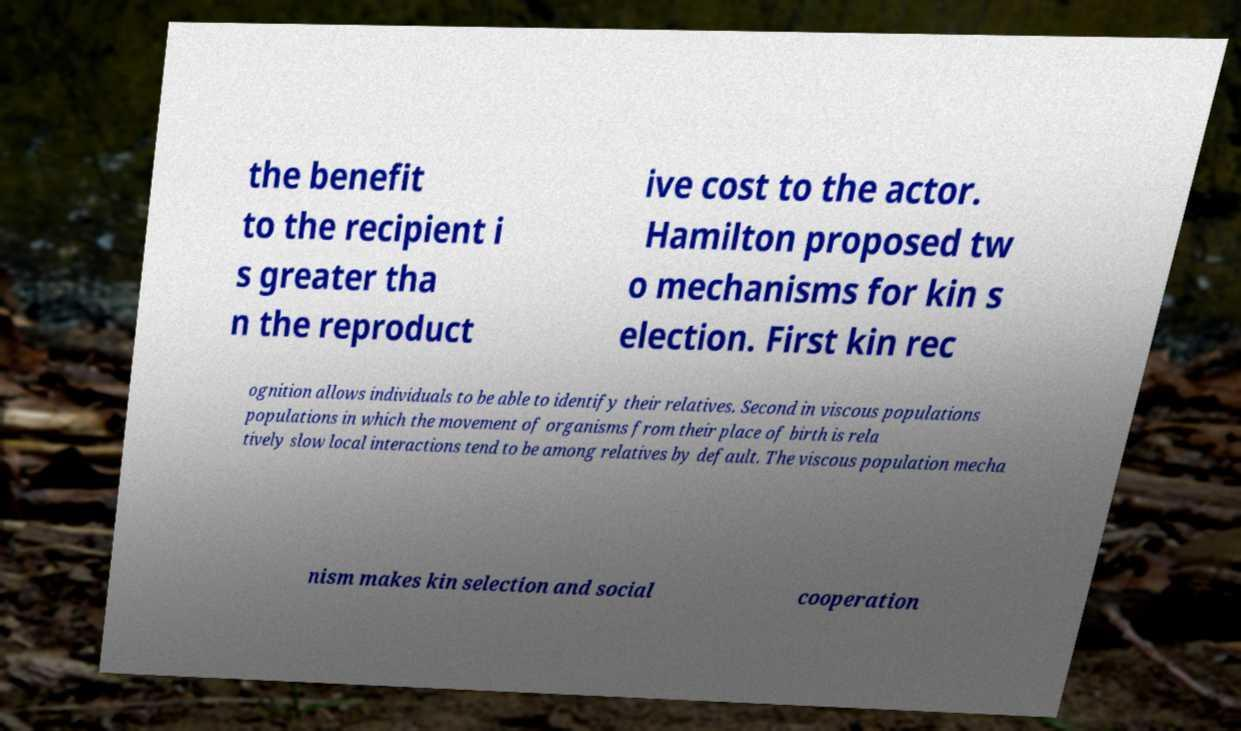Could you extract and type out the text from this image? the benefit to the recipient i s greater tha n the reproduct ive cost to the actor. Hamilton proposed tw o mechanisms for kin s election. First kin rec ognition allows individuals to be able to identify their relatives. Second in viscous populations populations in which the movement of organisms from their place of birth is rela tively slow local interactions tend to be among relatives by default. The viscous population mecha nism makes kin selection and social cooperation 